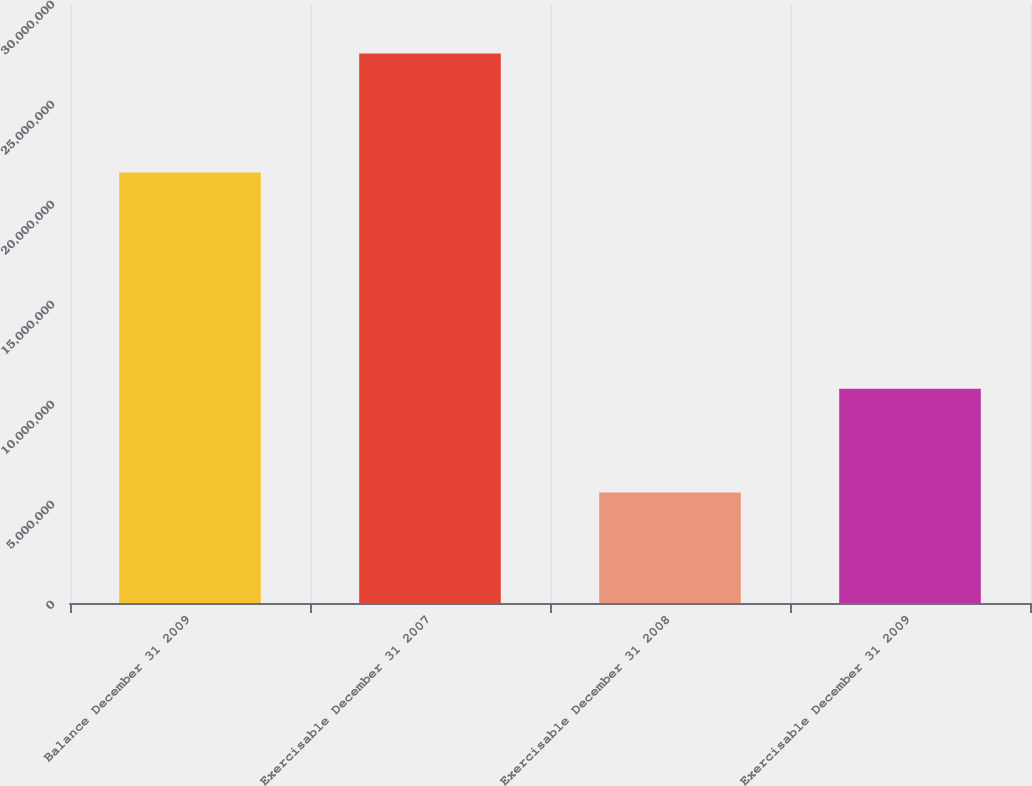Convert chart to OTSL. <chart><loc_0><loc_0><loc_500><loc_500><bar_chart><fcel>Balance December 31 2009<fcel>Exercisable December 31 2007<fcel>Exercisable December 31 2008<fcel>Exercisable December 31 2009<nl><fcel>2.15209e+07<fcel>2.74805e+07<fcel>5.52972e+06<fcel>1.07094e+07<nl></chart> 